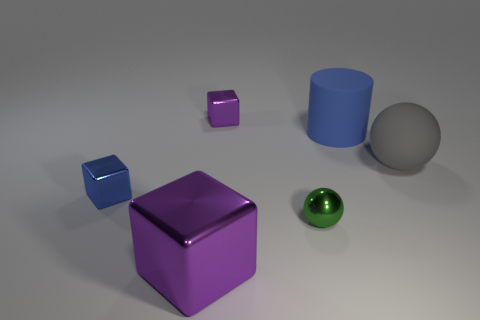Subtract all big blocks. How many blocks are left? 2 Add 4 small gray metallic objects. How many objects exist? 10 Subtract all brown cylinders. How many purple blocks are left? 2 Subtract 1 cylinders. How many cylinders are left? 0 Subtract all green spheres. How many spheres are left? 1 Subtract all spheres. How many objects are left? 4 Subtract 1 blue cubes. How many objects are left? 5 Subtract all blue blocks. Subtract all blue cylinders. How many blocks are left? 2 Subtract all small green blocks. Subtract all large purple blocks. How many objects are left? 5 Add 2 cylinders. How many cylinders are left? 3 